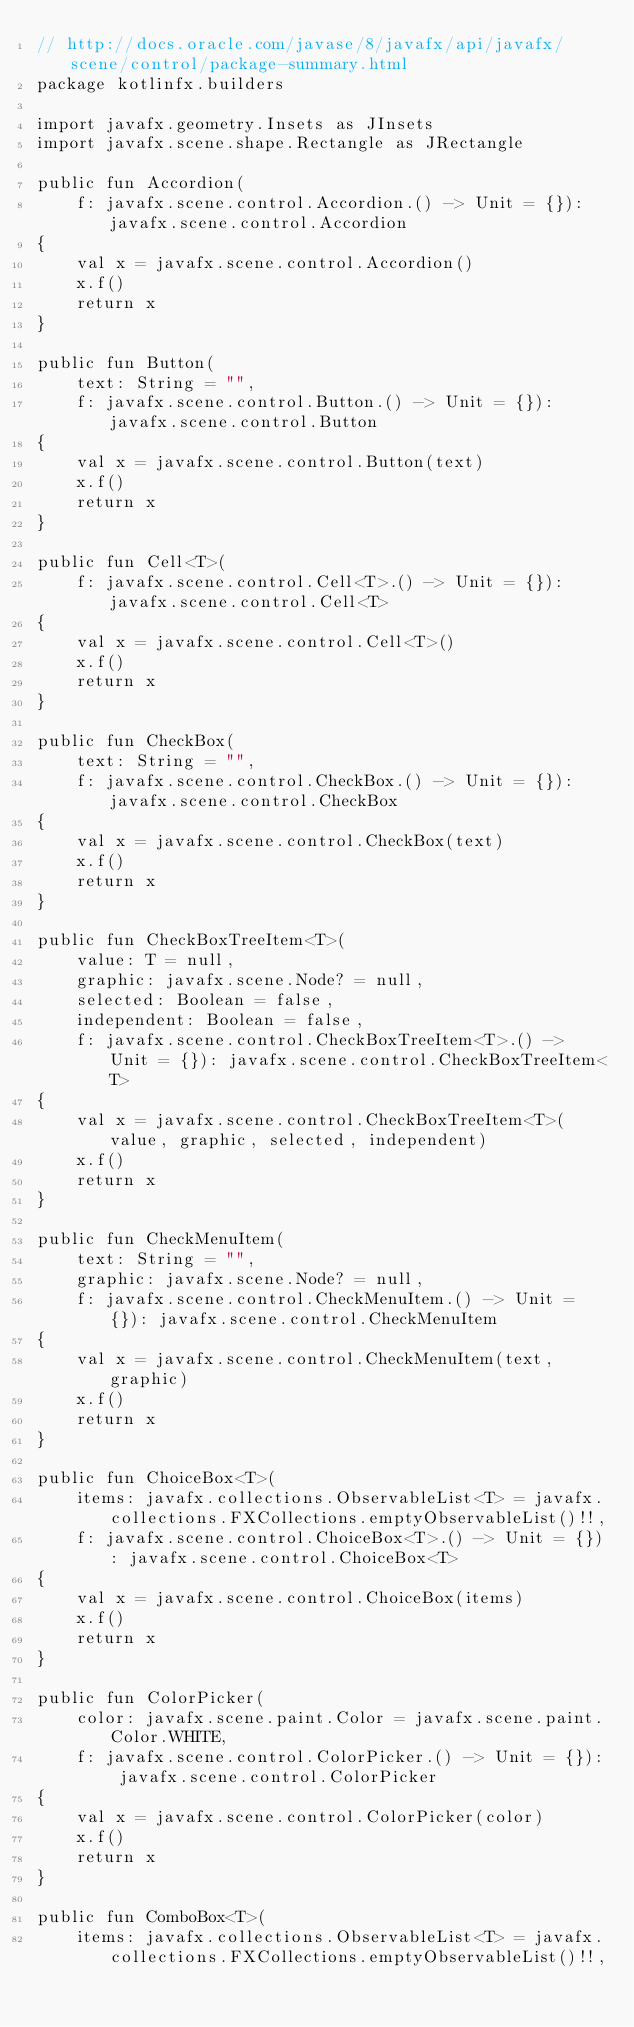Convert code to text. <code><loc_0><loc_0><loc_500><loc_500><_Kotlin_>// http://docs.oracle.com/javase/8/javafx/api/javafx/scene/control/package-summary.html
package kotlinfx.builders

import javafx.geometry.Insets as JInsets
import javafx.scene.shape.Rectangle as JRectangle

public fun Accordion(
    f: javafx.scene.control.Accordion.() -> Unit = {}): javafx.scene.control.Accordion
{
    val x = javafx.scene.control.Accordion()
    x.f()
    return x
}

public fun Button(
    text: String = "",
    f: javafx.scene.control.Button.() -> Unit = {}): javafx.scene.control.Button
{
    val x = javafx.scene.control.Button(text)
    x.f()
    return x
}

public fun Cell<T>(
    f: javafx.scene.control.Cell<T>.() -> Unit = {}): javafx.scene.control.Cell<T>
{
    val x = javafx.scene.control.Cell<T>()
    x.f()
    return x
}

public fun CheckBox(
    text: String = "",
    f: javafx.scene.control.CheckBox.() -> Unit = {}): javafx.scene.control.CheckBox
{
    val x = javafx.scene.control.CheckBox(text)
    x.f()
    return x
}

public fun CheckBoxTreeItem<T>(
    value: T = null,
    graphic: javafx.scene.Node? = null,
    selected: Boolean = false,
    independent: Boolean = false,
    f: javafx.scene.control.CheckBoxTreeItem<T>.() -> Unit = {}): javafx.scene.control.CheckBoxTreeItem<T>
{
    val x = javafx.scene.control.CheckBoxTreeItem<T>(value, graphic, selected, independent)
    x.f()
    return x
}

public fun CheckMenuItem(
    text: String = "",
    graphic: javafx.scene.Node? = null,
    f: javafx.scene.control.CheckMenuItem.() -> Unit = {}): javafx.scene.control.CheckMenuItem
{
    val x = javafx.scene.control.CheckMenuItem(text, graphic)
    x.f()
    return x
}

public fun ChoiceBox<T>(
    items: javafx.collections.ObservableList<T> = javafx.collections.FXCollections.emptyObservableList()!!,
    f: javafx.scene.control.ChoiceBox<T>.() -> Unit = {}): javafx.scene.control.ChoiceBox<T>
{
    val x = javafx.scene.control.ChoiceBox(items)
    x.f()
    return x
}

public fun ColorPicker(
    color: javafx.scene.paint.Color = javafx.scene.paint.Color.WHITE,
    f: javafx.scene.control.ColorPicker.() -> Unit = {}): javafx.scene.control.ColorPicker
{
    val x = javafx.scene.control.ColorPicker(color)
    x.f()
    return x
}

public fun ComboBox<T>(
    items: javafx.collections.ObservableList<T> = javafx.collections.FXCollections.emptyObservableList()!!,</code> 